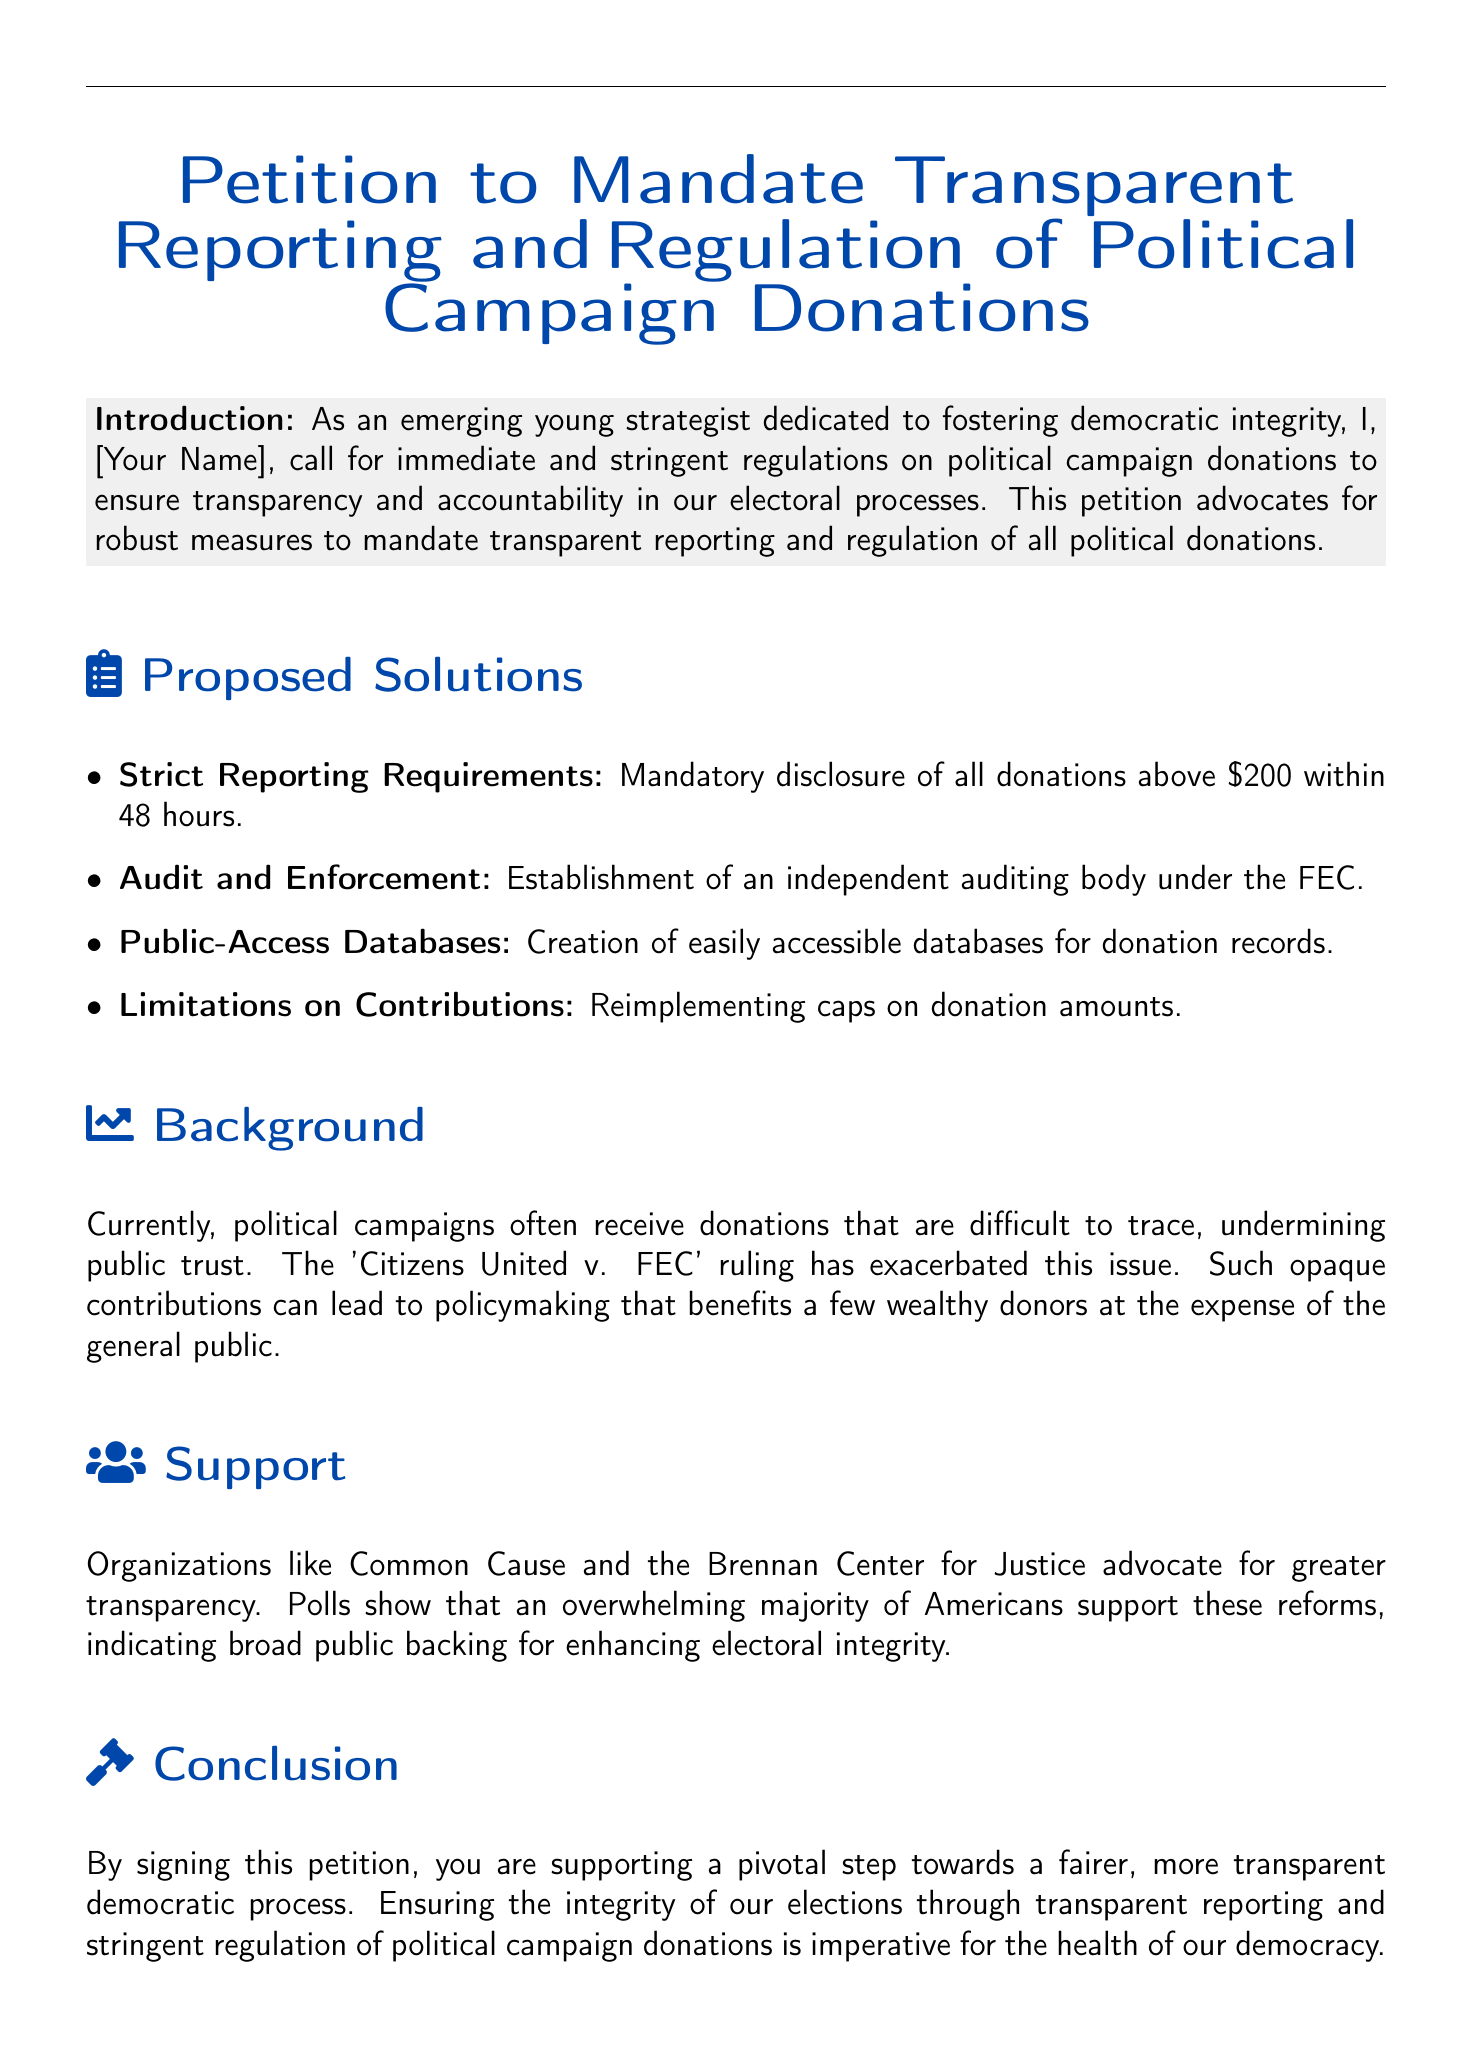What is the title of the petition? The title presents the main focus of the document, which is the call for transparency in political donations.
Answer: Petition to Mandate Transparent Reporting and Regulation of Political Campaign Donations What is the main goal of the petition? The introduction outlines the primary aim of the petition, emphasizing the urgency for regulation.
Answer: Transparency and accountability How many days are specified for mandatory disclosure of donations? The proposed solutions detail the timeline for reporting donations, highlighting efficiency.
Answer: 48 hours What organizations support the cause mentioned in the petition? The support section specifies organizations that advocate for the transparency initiatives stated in the petition.
Answer: Common Cause and the Brennan Center for Justice What ruling exacerbates the issue of opaque donations? The background section identifies legal precedents that have affected the transparency of political contributions.
Answer: Citizens United v. FEC What is urged of the Federal Election Commission? The call to action emphasizes the specific actions requested from regulatory bodies concerning donations.
Answer: Immediate action What is the consequence of difficult-to-trace donations mentioned in the document? The background highlights the negative impact of such donations on public sentiment and trust in governance.
Answer: Undermining public trust What should be included in the signature section? The document specifies what personal information is required from individuals supporting the petition.
Answer: Signature, Date, Printed Name, Email 